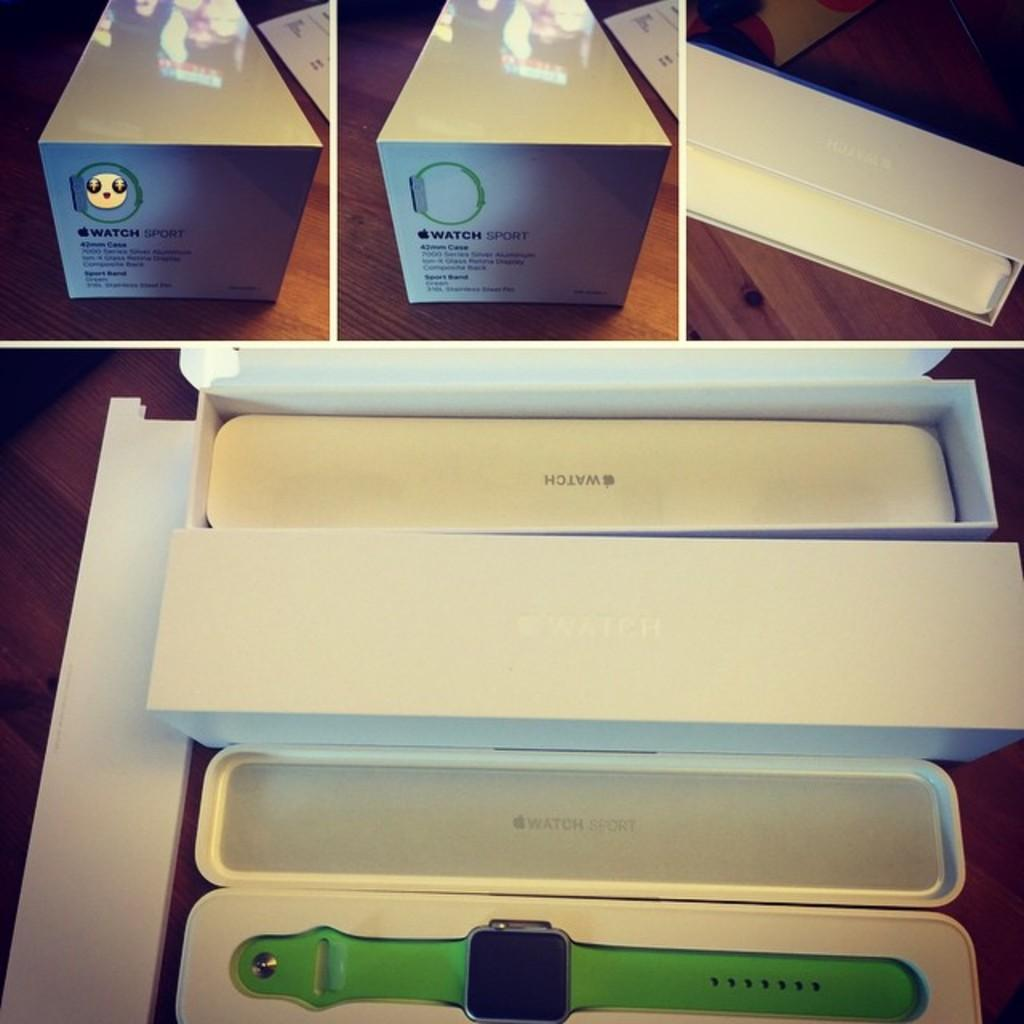Provide a one-sentence caption for the provided image. A green watch sport watch in a white box. 